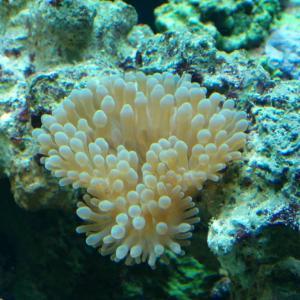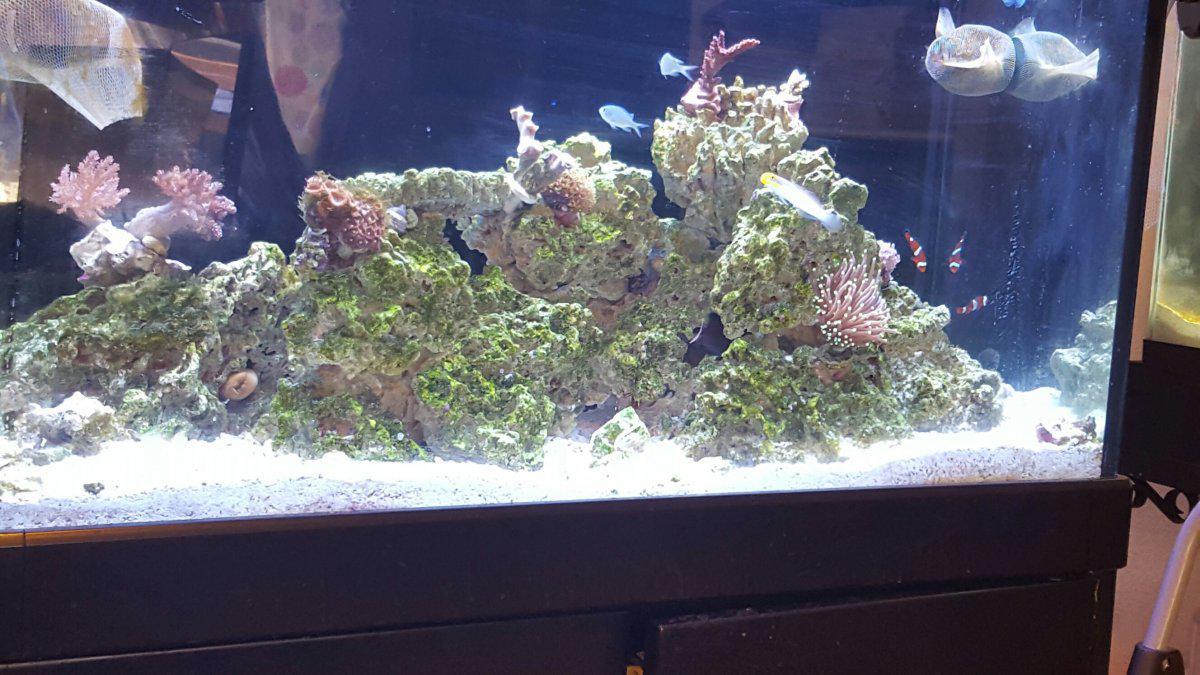The first image is the image on the left, the second image is the image on the right. Given the left and right images, does the statement "Fish and coral are shown." hold true? Answer yes or no. Yes. The first image is the image on the left, the second image is the image on the right. Evaluate the accuracy of this statement regarding the images: "In at least one image there is a fish tank holding at least one fish.". Is it true? Answer yes or no. Yes. 